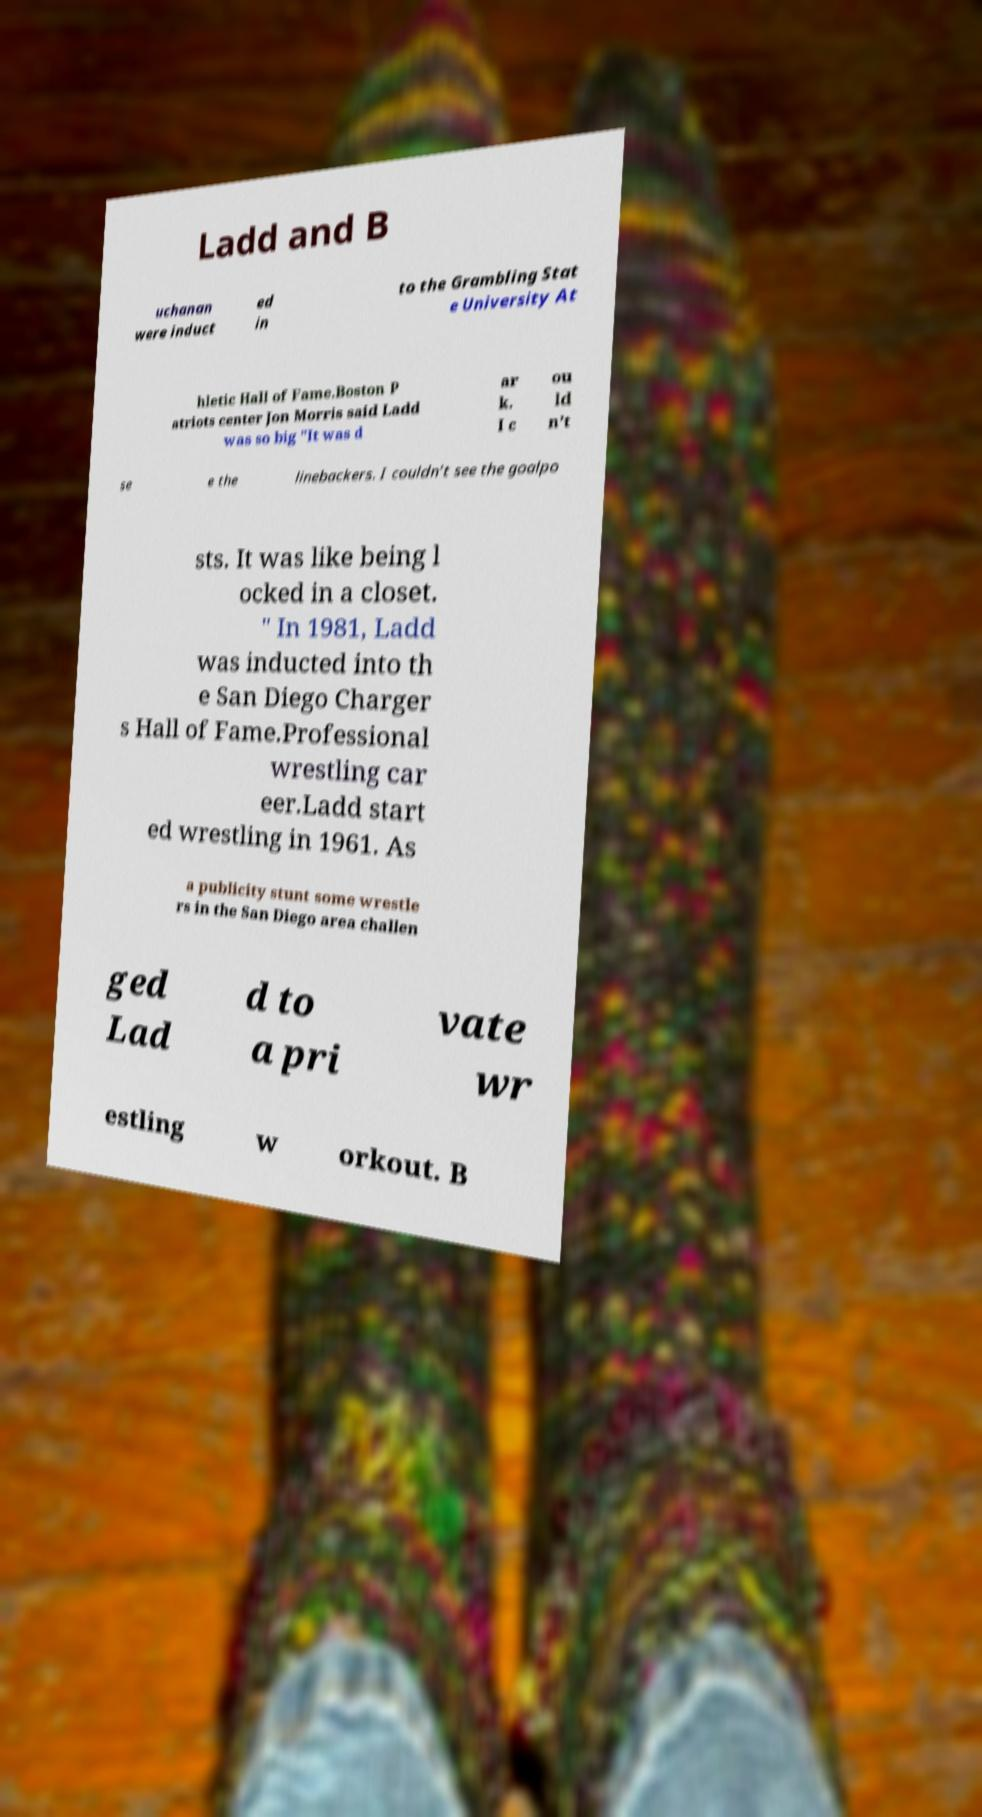Could you extract and type out the text from this image? Ladd and B uchanan were induct ed in to the Grambling Stat e University At hletic Hall of Fame.Boston P atriots center Jon Morris said Ladd was so big "It was d ar k. I c ou ld n’t se e the linebackers. I couldn’t see the goalpo sts. It was like being l ocked in a closet. " In 1981, Ladd was inducted into th e San Diego Charger s Hall of Fame.Professional wrestling car eer.Ladd start ed wrestling in 1961. As a publicity stunt some wrestle rs in the San Diego area challen ged Lad d to a pri vate wr estling w orkout. B 